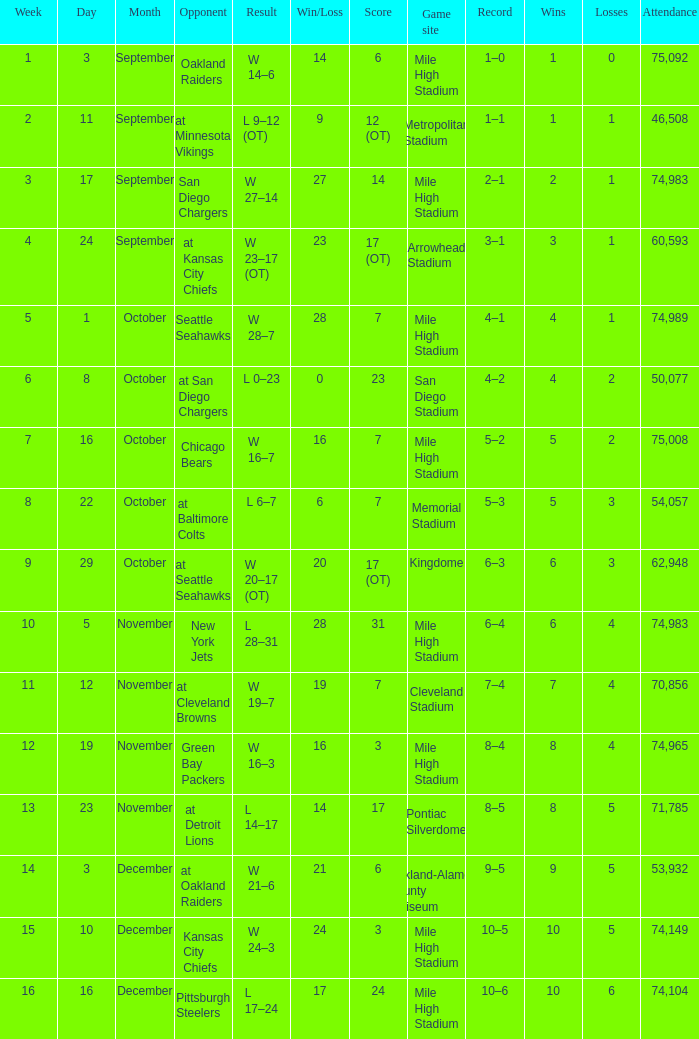Which week has a record of 5–2? 7.0. 